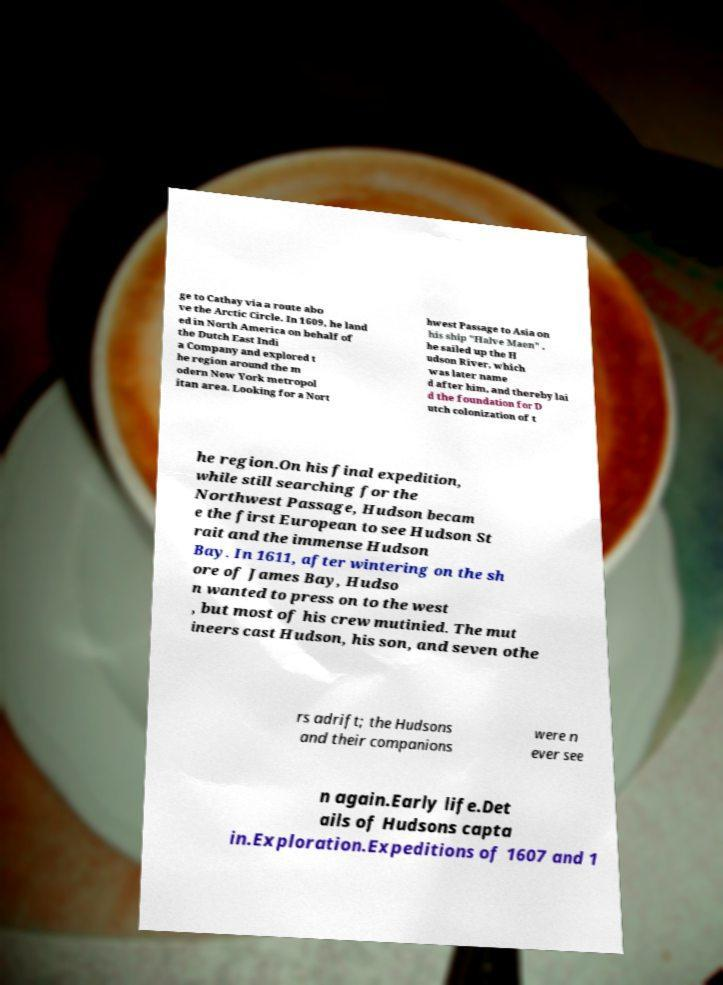Could you assist in decoding the text presented in this image and type it out clearly? ge to Cathay via a route abo ve the Arctic Circle. In 1609, he land ed in North America on behalf of the Dutch East Indi a Company and explored t he region around the m odern New York metropol itan area. Looking for a Nort hwest Passage to Asia on his ship "Halve Maen" , he sailed up the H udson River, which was later name d after him, and thereby lai d the foundation for D utch colonization of t he region.On his final expedition, while still searching for the Northwest Passage, Hudson becam e the first European to see Hudson St rait and the immense Hudson Bay. In 1611, after wintering on the sh ore of James Bay, Hudso n wanted to press on to the west , but most of his crew mutinied. The mut ineers cast Hudson, his son, and seven othe rs adrift; the Hudsons and their companions were n ever see n again.Early life.Det ails of Hudsons capta in.Exploration.Expeditions of 1607 and 1 